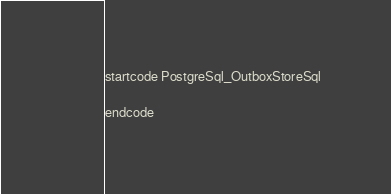<code> <loc_0><loc_0><loc_500><loc_500><_SQL_>startcode PostgreSql_OutboxStoreSql

endcode
</code> 